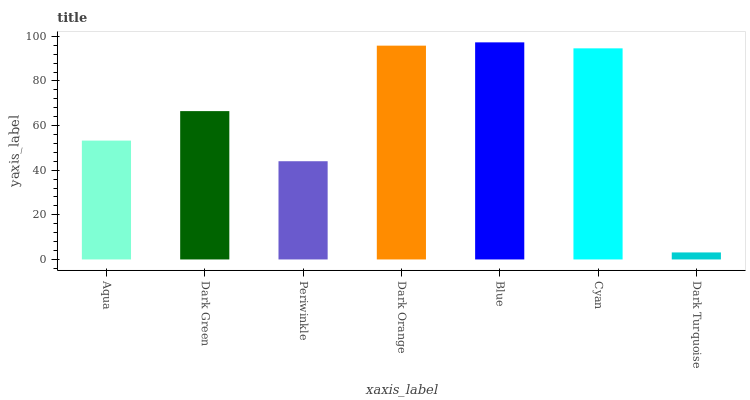Is Dark Turquoise the minimum?
Answer yes or no. Yes. Is Blue the maximum?
Answer yes or no. Yes. Is Dark Green the minimum?
Answer yes or no. No. Is Dark Green the maximum?
Answer yes or no. No. Is Dark Green greater than Aqua?
Answer yes or no. Yes. Is Aqua less than Dark Green?
Answer yes or no. Yes. Is Aqua greater than Dark Green?
Answer yes or no. No. Is Dark Green less than Aqua?
Answer yes or no. No. Is Dark Green the high median?
Answer yes or no. Yes. Is Dark Green the low median?
Answer yes or no. Yes. Is Dark Turquoise the high median?
Answer yes or no. No. Is Periwinkle the low median?
Answer yes or no. No. 